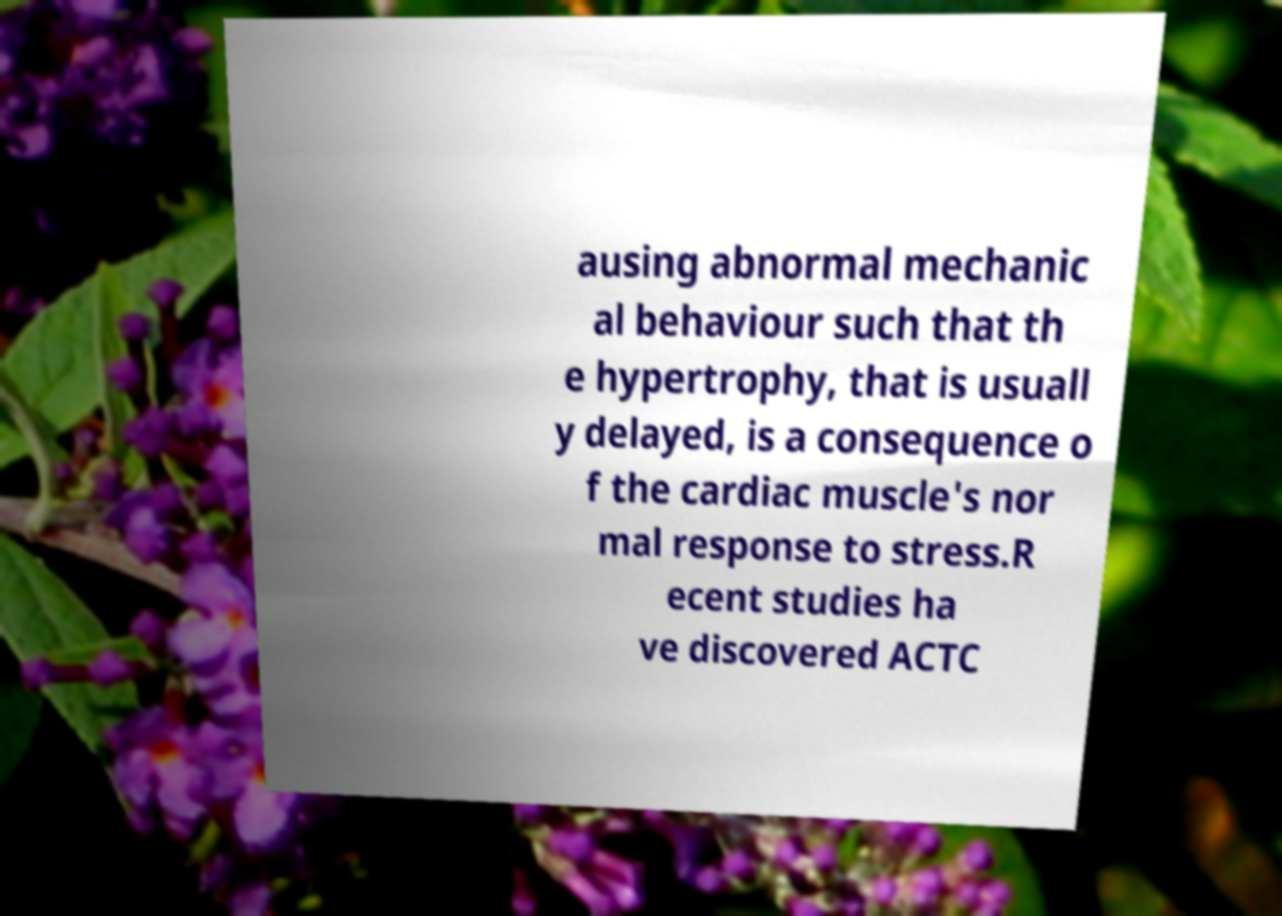For documentation purposes, I need the text within this image transcribed. Could you provide that? ausing abnormal mechanic al behaviour such that th e hypertrophy, that is usuall y delayed, is a consequence o f the cardiac muscle's nor mal response to stress.R ecent studies ha ve discovered ACTC 